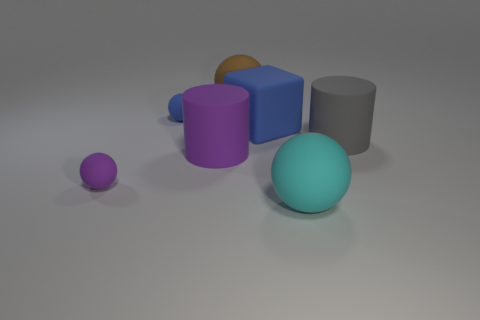Are there more large brown spheres than gray rubber spheres?
Give a very brief answer. Yes. How many other things are the same material as the tiny blue object?
Your answer should be very brief. 6. What number of objects are tiny yellow rubber things or rubber balls that are on the right side of the big blue object?
Your answer should be very brief. 1. Are there fewer large objects than large blue cylinders?
Your response must be concise. No. What is the color of the tiny thing that is behind the blue matte object that is to the right of the matte sphere behind the small blue object?
Your answer should be compact. Blue. Is the material of the small purple thing the same as the small blue object?
Give a very brief answer. Yes. What number of matte cylinders are in front of the purple matte cylinder?
Make the answer very short. 0. The blue object that is the same shape as the tiny purple rubber object is what size?
Your answer should be very brief. Small. How many green things are either big matte spheres or large rubber blocks?
Provide a short and direct response. 0. There is a large matte sphere that is right of the brown sphere; how many big spheres are to the left of it?
Your response must be concise. 1. 